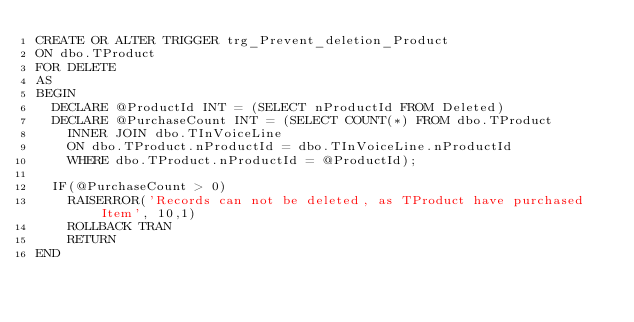<code> <loc_0><loc_0><loc_500><loc_500><_SQL_>CREATE OR ALTER TRIGGER trg_Prevent_deletion_Product
ON dbo.TProduct
FOR DELETE
AS
BEGIN
	DECLARE @ProductId INT = (SELECT nProductId FROM Deleted)
	DECLARE @PurchaseCount INT = (SELECT COUNT(*) FROM dbo.TProduct
		INNER JOIN dbo.TInVoiceLine
		ON dbo.TProduct.nProductId = dbo.TInVoiceLine.nProductId
		WHERE dbo.TProduct.nProductId = @ProductId);

	IF(@PurchaseCount > 0)
		RAISERROR('Records can not be deleted, as TProduct have purchased Item', 10,1)
		ROLLBACK TRAN
		RETURN
END

</code> 